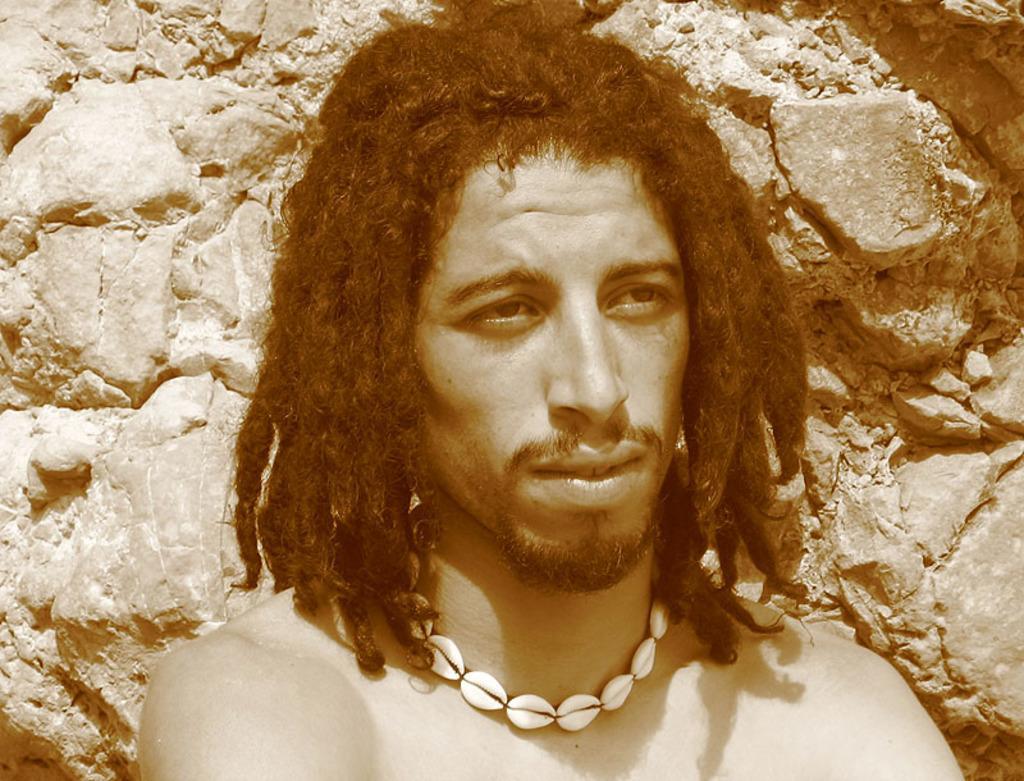In one or two sentences, can you explain what this image depicts? In this picture, we see a man who is wearing a chain which is made up of seashells. He has long hair. Behind him, we see the rocks. 